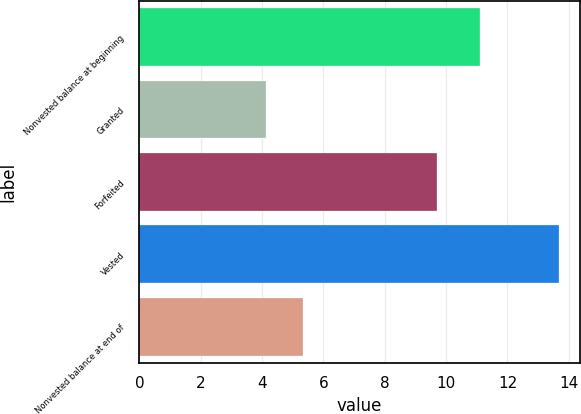Convert chart. <chart><loc_0><loc_0><loc_500><loc_500><bar_chart><fcel>Nonvested balance at beginning<fcel>Granted<fcel>Forfeited<fcel>Vested<fcel>Nonvested balance at end of<nl><fcel>11.09<fcel>4.12<fcel>9.7<fcel>13.68<fcel>5.32<nl></chart> 